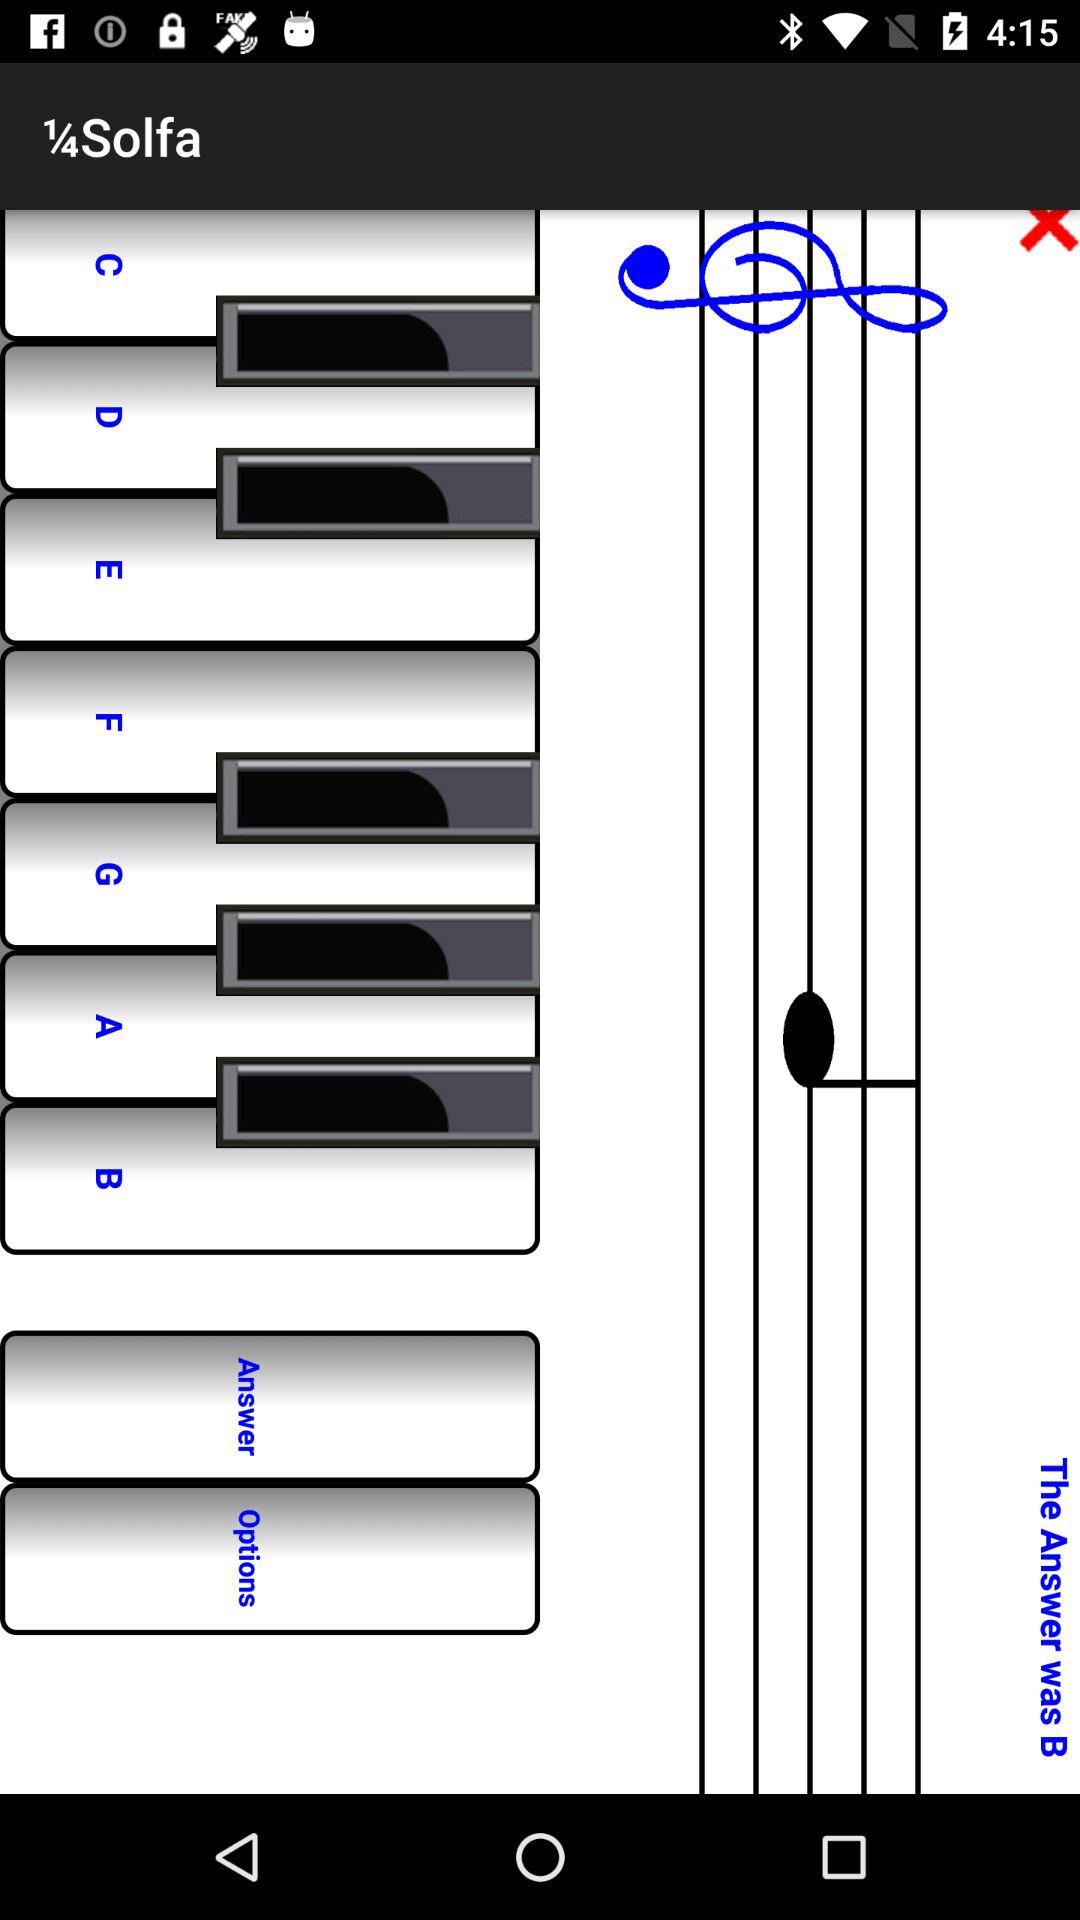What was the answer? The answer was B. 